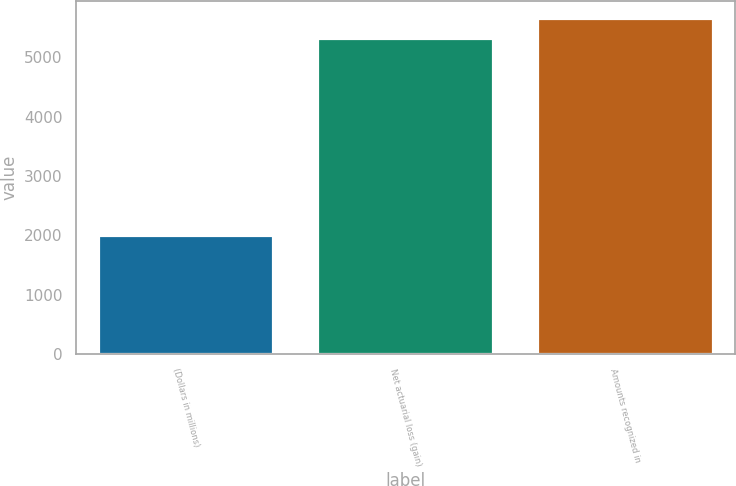Convert chart. <chart><loc_0><loc_0><loc_500><loc_500><bar_chart><fcel>(Dollars in millions)<fcel>Net actuarial loss (gain)<fcel>Amounts recognized in<nl><fcel>2014<fcel>5328<fcel>5660.5<nl></chart> 